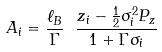<formula> <loc_0><loc_0><loc_500><loc_500>A _ { i } = \frac { \ell _ { B } } \Gamma \ \frac { z _ { i } - \frac { 1 } { 2 } \sigma _ { i } ^ { 2 } P _ { z } } { 1 + \Gamma \sigma _ { i } }</formula> 